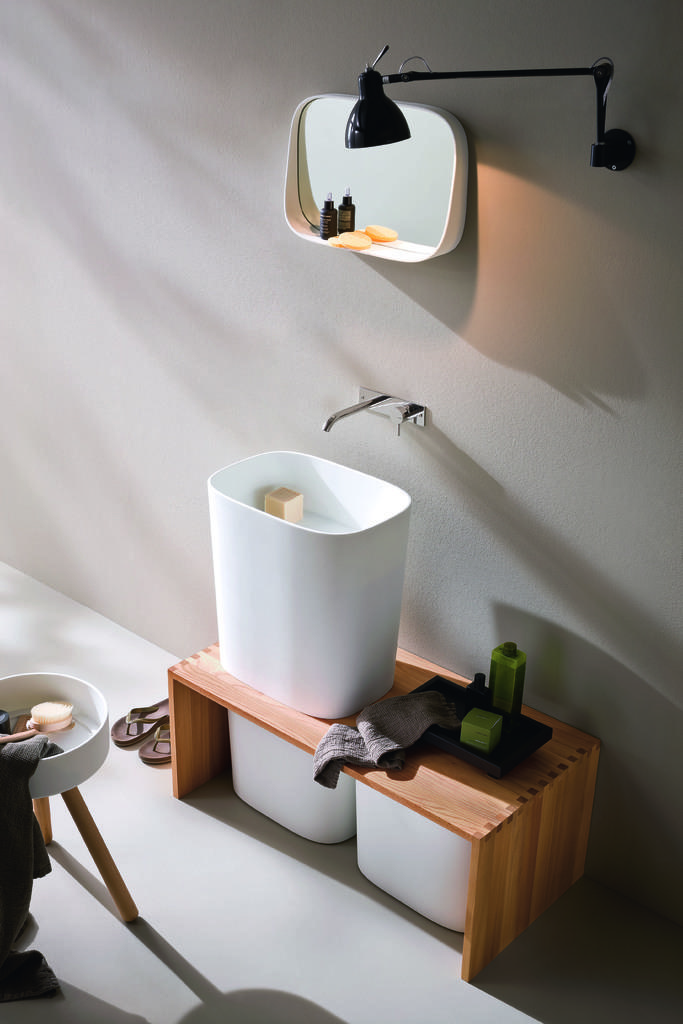What type of room is the image taken in? The image appears to be taken in a washroom. What can be seen in the middle of the image? There is a mirror in the middle of the image. What is located near the mirror? Soap is present near the mirror. What is on the small table in front of the mirror? There is a basket on the small table. What provides light in the image? There is a hanging light on the wall. What type of fruit is hanging from the ceiling in the image? There is no fruit hanging from the ceiling in the image. How many houses are visible in the image? There are no houses visible in the image. 